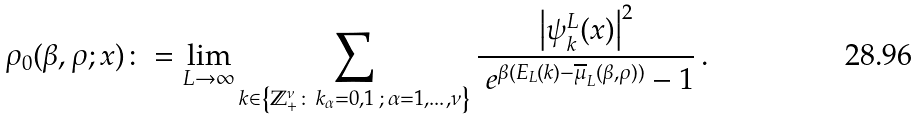<formula> <loc_0><loc_0><loc_500><loc_500>\rho _ { 0 } ( \beta , \rho ; x ) \colon = \lim _ { L \rightarrow \infty } \sum _ { k \in \left \{ \mathbb { Z } _ { + } ^ { \nu } \colon \, k _ { \alpha } = 0 , 1 \, ; \, \alpha = 1 , \dots , \nu \right \} } \frac { \left | \psi _ { k } ^ { L } ( x ) \right | ^ { 2 } } { \ e ^ { \beta ( E _ { L } ( k ) - \overline { \mu } _ { L } ( \beta , \rho ) ) } - 1 } \, .</formula> 